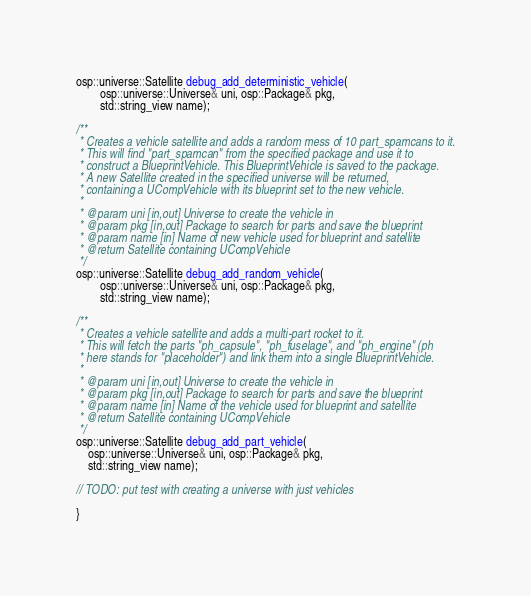<code> <loc_0><loc_0><loc_500><loc_500><_C_>osp::universe::Satellite debug_add_deterministic_vehicle(
        osp::universe::Universe& uni, osp::Package& pkg,
        std::string_view name);

/**
 * Creates a vehicle satellite and adds a random mess of 10 part_spamcans to it.
 * This will find "part_spamcan" from the specified package and use it to
 * construct a BlueprintVehicle. This BlueprintVehicle is saved to the package.
 * A new Satellite created in the specified universe will be returned,
 * containing a UCompVehicle with its blueprint set to the new vehicle.
 *
 * @param uni [in,out] Universe to create the vehicle in
 * @param pkg [in,out] Package to search for parts and save the blueprint
 * @param name [in] Name of new vehicle used for blueprint and satellite
 * @return Satellite containing UCompVehicle
 */
osp::universe::Satellite debug_add_random_vehicle(
        osp::universe::Universe& uni, osp::Package& pkg,
        std::string_view name);

/**
 * Creates a vehicle satellite and adds a multi-part rocket to it.
 * This will fetch the parts "ph_capsule", "ph_fuselage", and "ph_engine" (ph
 * here stands for "placeholder") and link them into a single BlueprintVehicle.
 *
 * @param uni [in,out] Universe to create the vehicle in
 * @param pkg [in,out] Package to search for parts and save the blueprint
 * @param name [in] Name of the vehicle used for blueprint and satellite
 * @return Satellite containing UCompVehicle
 */
osp::universe::Satellite debug_add_part_vehicle(
    osp::universe::Universe& uni, osp::Package& pkg,
    std::string_view name);

// TODO: put test with creating a universe with just vehicles

}
</code> 